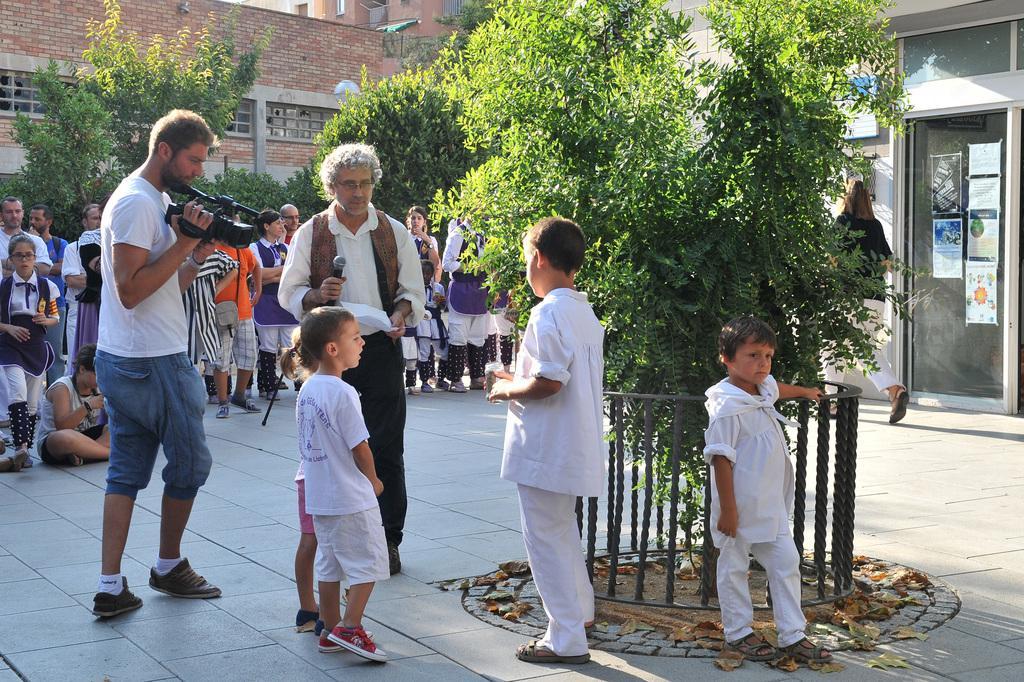How would you summarize this image in a sentence or two? In this image we can see three children are standing. They are wearing white color dress and two men are standing. One man is wearing white color shirt with black pant and holding paper and mic. The other man is wearing white color t-shirt with shorts and holding camera in his hand. Behind them buildings, trees and people are present. 